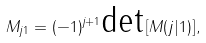Convert formula to latex. <formula><loc_0><loc_0><loc_500><loc_500>M _ { j 1 } = ( - 1 ) ^ { j + 1 } \text {det} \left [ M ( j | 1 ) \right ] ,</formula> 